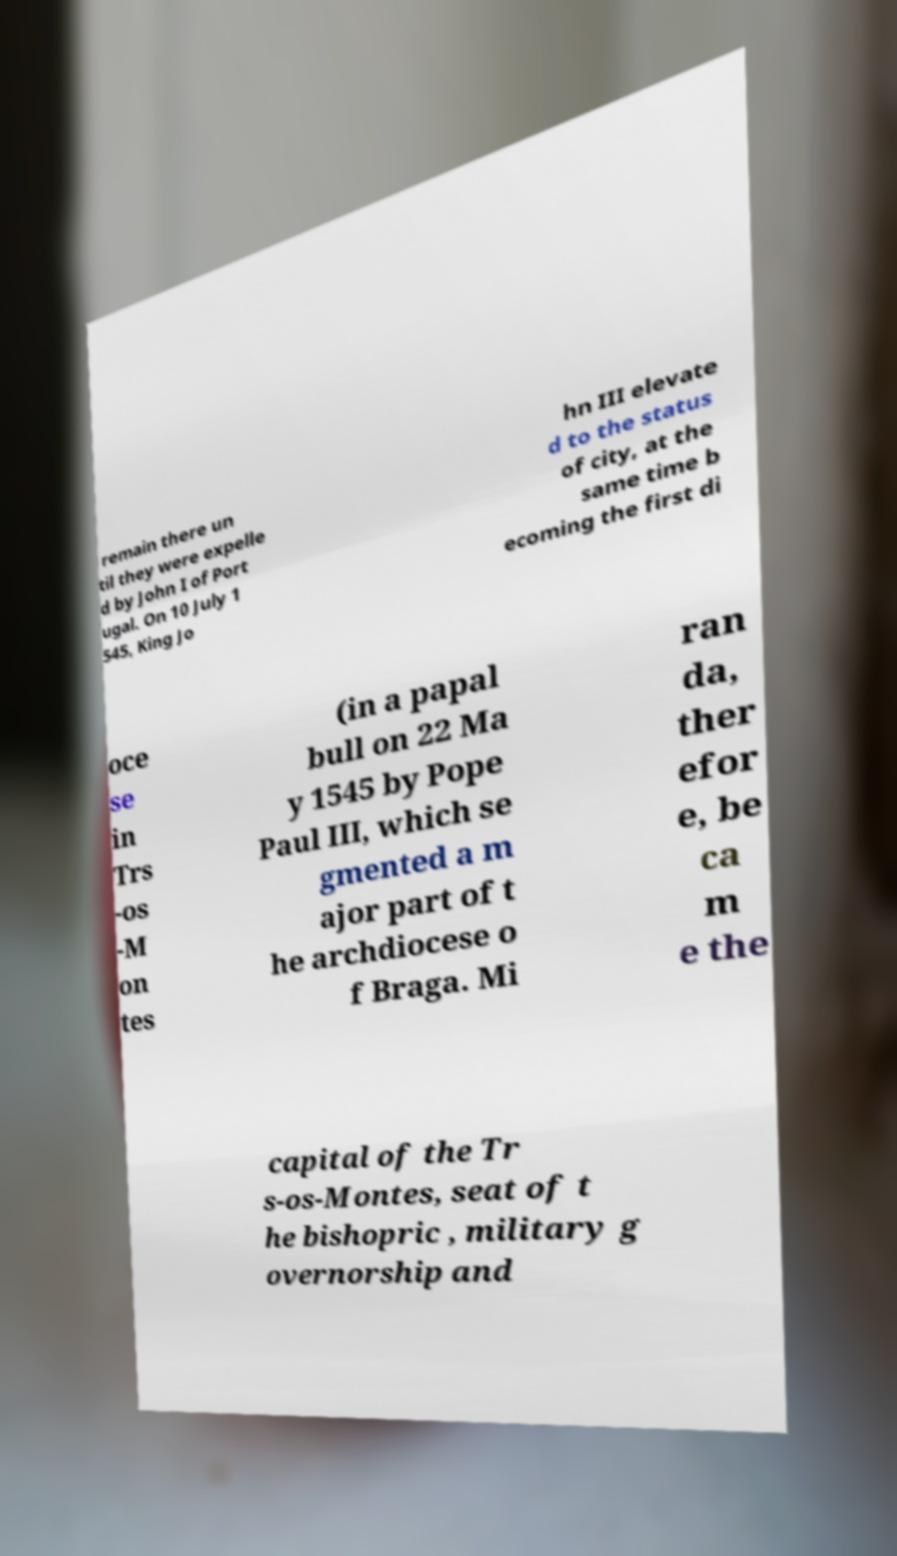Please identify and transcribe the text found in this image. remain there un til they were expelle d by John I of Port ugal. On 10 July 1 545, King Jo hn III elevate d to the status of city, at the same time b ecoming the first di oce se in Trs -os -M on tes (in a papal bull on 22 Ma y 1545 by Pope Paul III, which se gmented a m ajor part of t he archdiocese o f Braga. Mi ran da, ther efor e, be ca m e the capital of the Tr s-os-Montes, seat of t he bishopric , military g overnorship and 